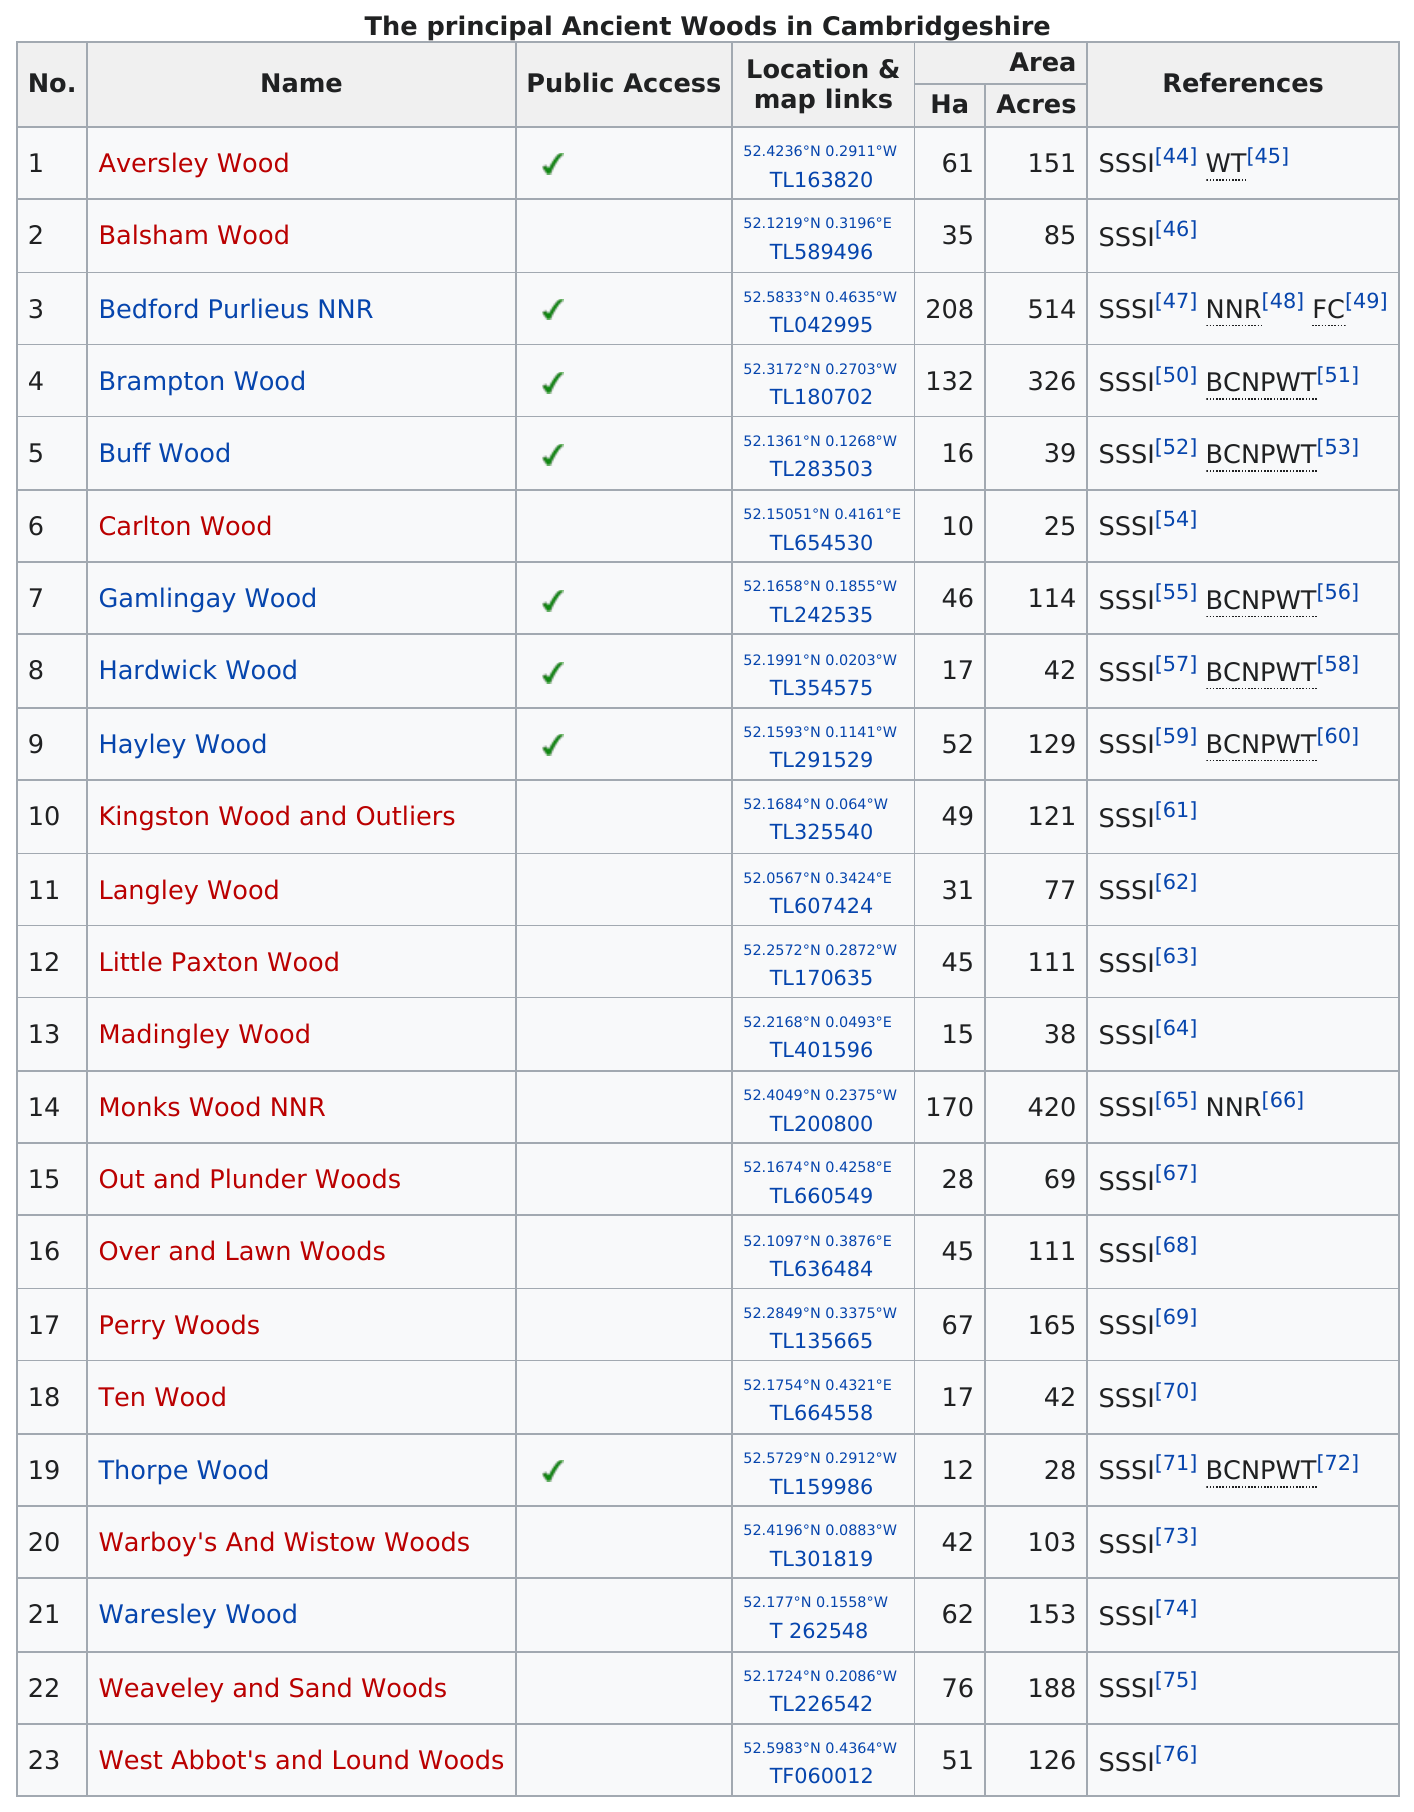Identify some key points in this picture. Hardwick Wood covers the same acreage as that of Ten Wood. The previous entry in the list is titled "Out and Plunder Woods.." and its name is "what is the name of the entry previous to no. 16? There are 4 woods whose names begin with the letter 'w'. Aversley Wood and Brampton Wood, when added together, total 477 acres. Eight ancient woods have public access. 